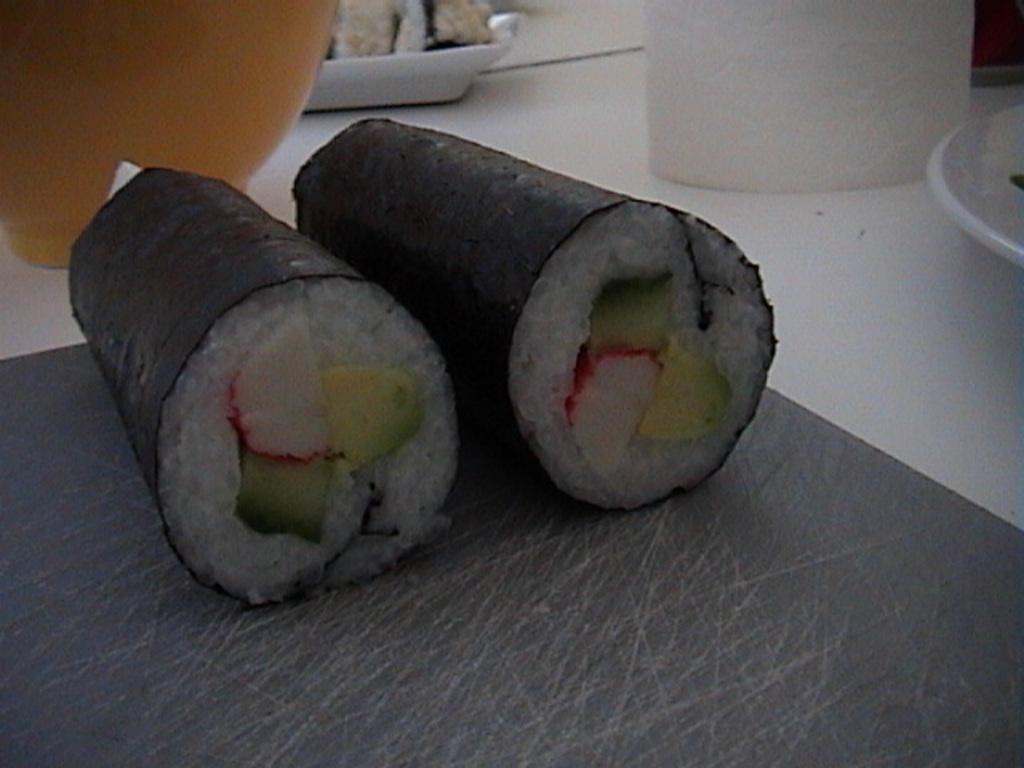Describe this image in one or two sentences. In this image I can see black and white colour food. I can also see few plates and few other stuffs. 